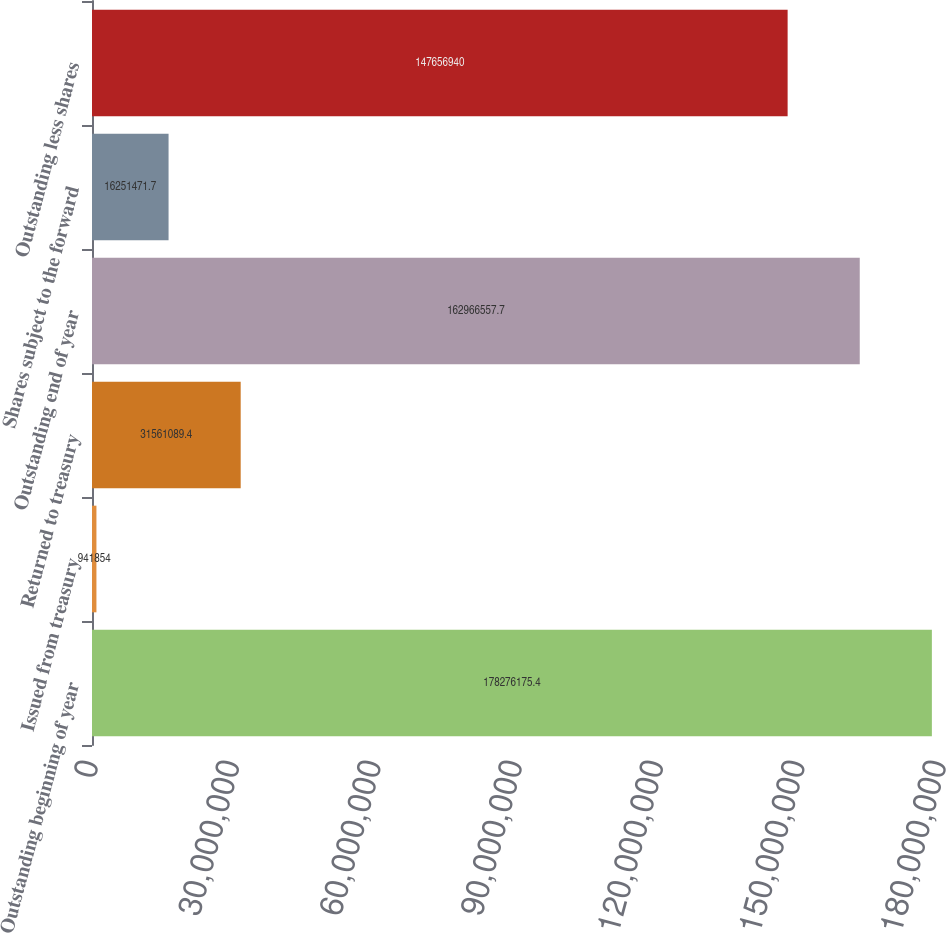Convert chart. <chart><loc_0><loc_0><loc_500><loc_500><bar_chart><fcel>Outstanding beginning of year<fcel>Issued from treasury<fcel>Returned to treasury<fcel>Outstanding end of year<fcel>Shares subject to the forward<fcel>Outstanding less shares<nl><fcel>1.78276e+08<fcel>941854<fcel>3.15611e+07<fcel>1.62967e+08<fcel>1.62515e+07<fcel>1.47657e+08<nl></chart> 